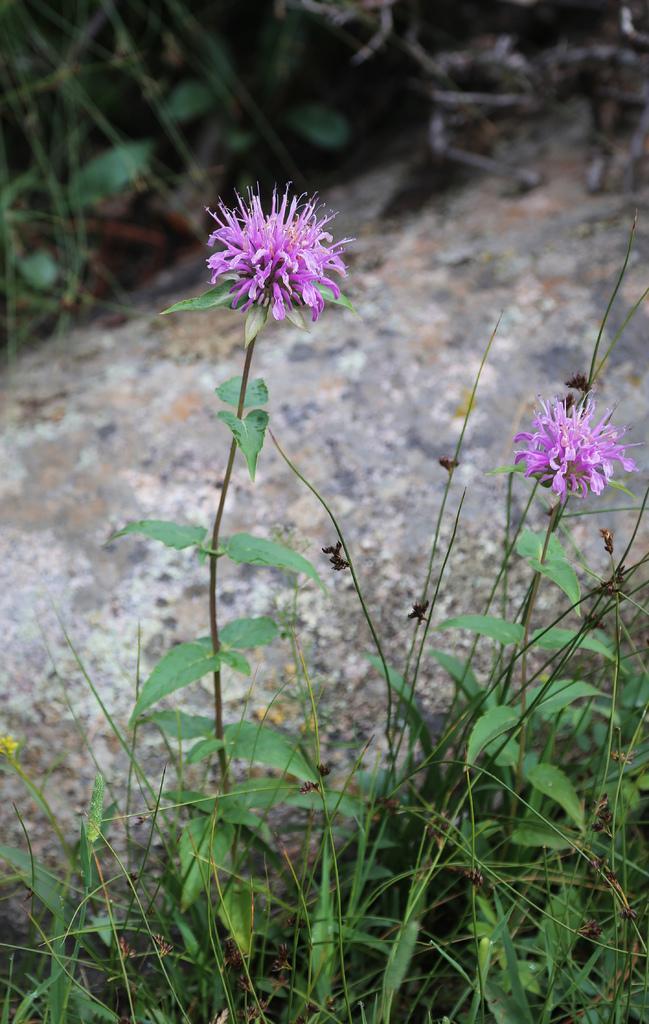Can you describe this image briefly? In this image we can see two flowers which are in same color pink and there are some plants present in this picture. 